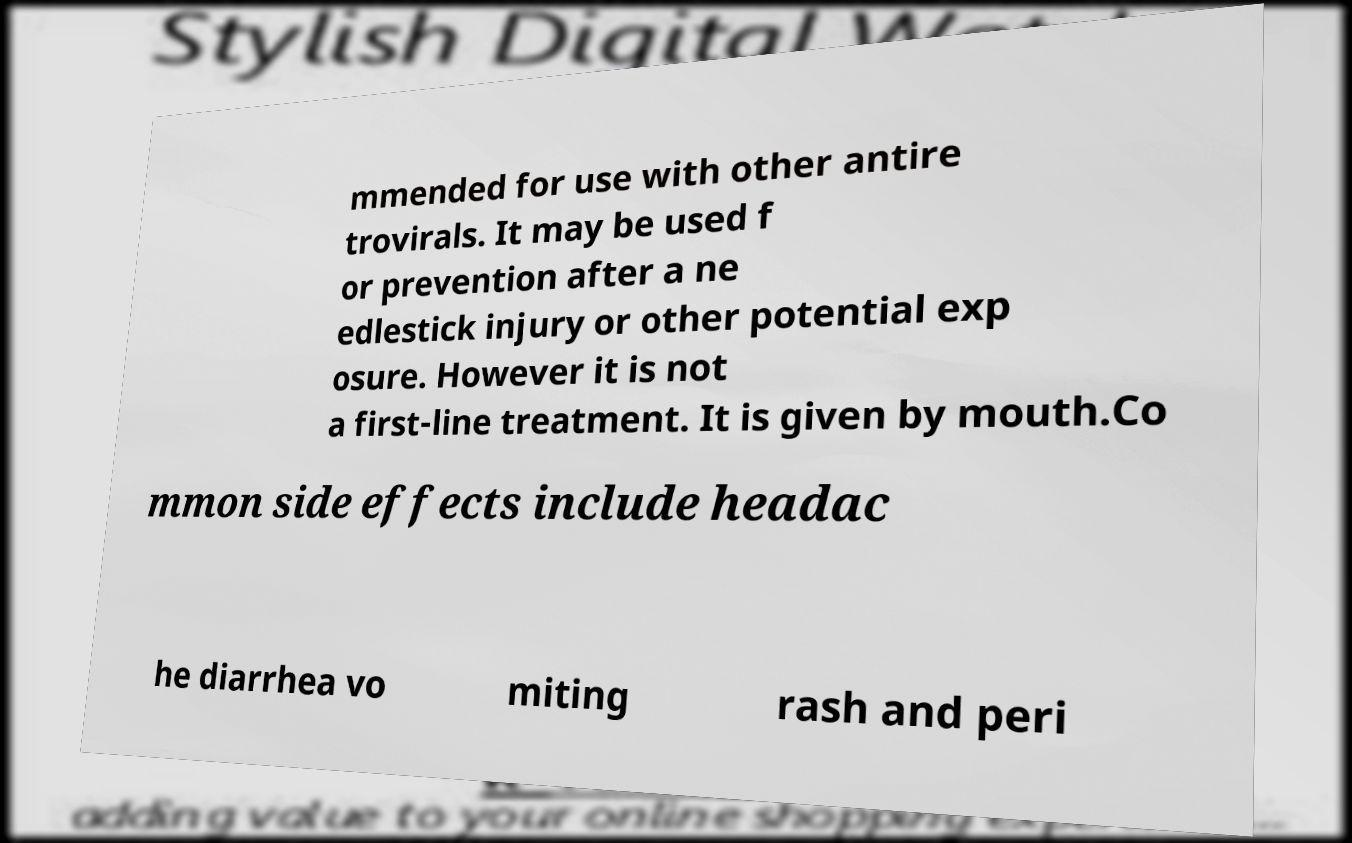I need the written content from this picture converted into text. Can you do that? mmended for use with other antire trovirals. It may be used f or prevention after a ne edlestick injury or other potential exp osure. However it is not a first-line treatment. It is given by mouth.Co mmon side effects include headac he diarrhea vo miting rash and peri 